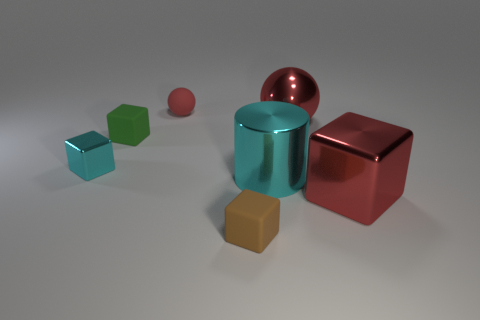What is the shape of the green thing that is the same size as the brown thing?
Your answer should be very brief. Cube. Are there any big objects of the same shape as the small brown object?
Provide a succinct answer. Yes. Is the small red object made of the same material as the cyan block in front of the large sphere?
Keep it short and to the point. No. Is there a large metal sphere of the same color as the large metallic cube?
Your answer should be compact. Yes. How many other things are there of the same material as the cylinder?
Make the answer very short. 3. Do the large metallic cylinder and the tiny cube that is to the right of the red rubber sphere have the same color?
Provide a succinct answer. No. Is the number of large balls left of the brown matte block greater than the number of shiny balls?
Your answer should be very brief. No. There is a tiny matte cube that is behind the small block on the right side of the small red thing; how many tiny cyan metal cubes are to the right of it?
Provide a succinct answer. 0. There is a large shiny object behind the tiny cyan object; does it have the same shape as the brown matte object?
Your answer should be very brief. No. There is a cyan thing to the right of the small brown object; what is it made of?
Provide a short and direct response. Metal. 